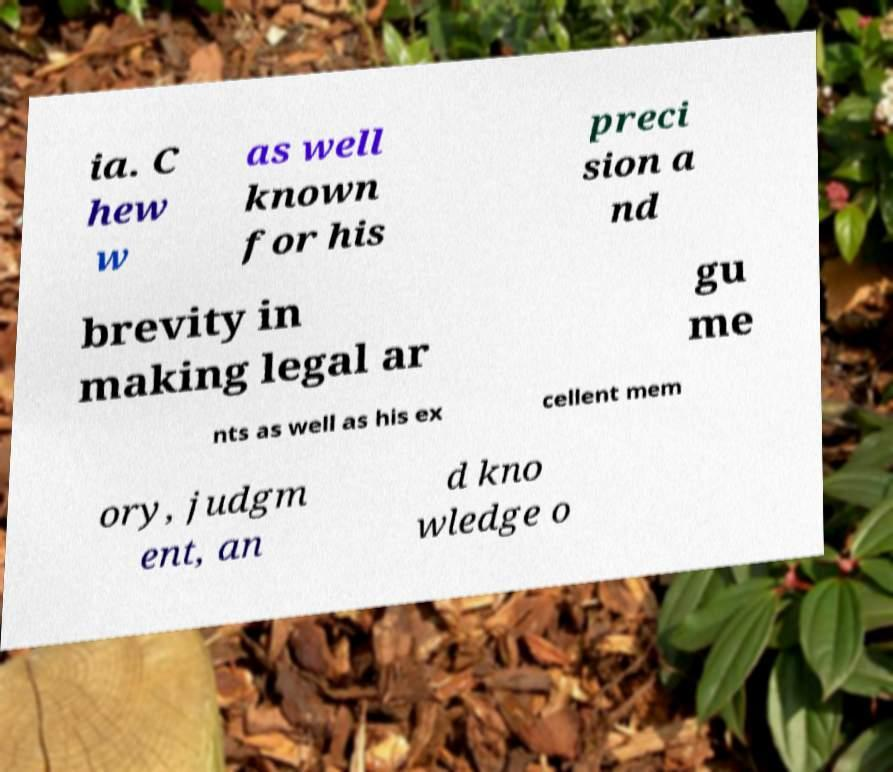Can you read and provide the text displayed in the image?This photo seems to have some interesting text. Can you extract and type it out for me? ia. C hew w as well known for his preci sion a nd brevity in making legal ar gu me nts as well as his ex cellent mem ory, judgm ent, an d kno wledge o 